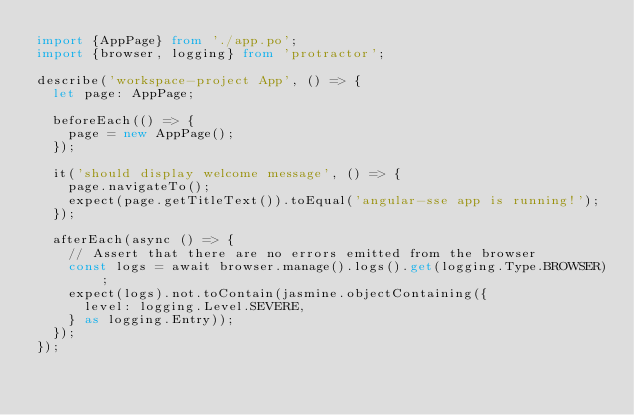<code> <loc_0><loc_0><loc_500><loc_500><_TypeScript_>import {AppPage} from './app.po';
import {browser, logging} from 'protractor';

describe('workspace-project App', () => {
  let page: AppPage;

  beforeEach(() => {
    page = new AppPage();
  });

  it('should display welcome message', () => {
    page.navigateTo();
    expect(page.getTitleText()).toEqual('angular-sse app is running!');
  });

  afterEach(async () => {
    // Assert that there are no errors emitted from the browser
    const logs = await browser.manage().logs().get(logging.Type.BROWSER);
    expect(logs).not.toContain(jasmine.objectContaining({
      level: logging.Level.SEVERE,
    } as logging.Entry));
  });
});
</code> 